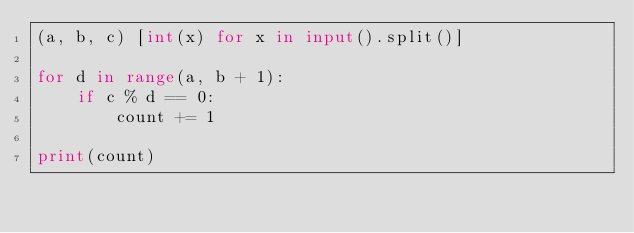<code> <loc_0><loc_0><loc_500><loc_500><_Python_>(a, b, c) [int(x) for x in input().split()]

for d in range(a, b + 1):
    if c % d == 0:
        count += 1

print(count)</code> 